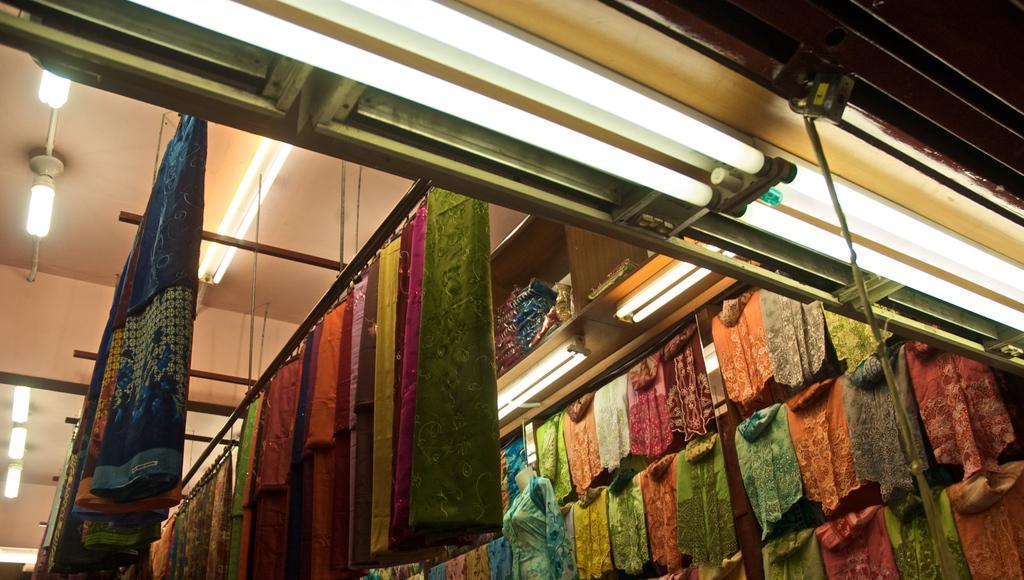Could you give a brief overview of what you see in this image? In the foreground of this image, there are many clothes hanging to the rods and also we can see few clothes in the shelf and lights to the ceiling. At the top, there is a shutter and few tube lights. 